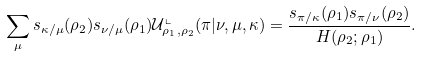Convert formula to latex. <formula><loc_0><loc_0><loc_500><loc_500>\sum _ { \mu } s _ { \kappa / \mu } ( \rho _ { 2 } ) s _ { \nu / \mu } ( \rho _ { 1 } ) \mathcal { U } ^ { \llcorner } _ { \rho _ { 1 } , \rho _ { 2 } } ( \pi | \nu , \mu , \kappa ) = \frac { s _ { \pi / \kappa } ( \rho _ { 1 } ) s _ { \pi / \nu } ( \rho _ { 2 } ) } { H ( \rho _ { 2 } ; \rho _ { 1 } ) } .</formula> 